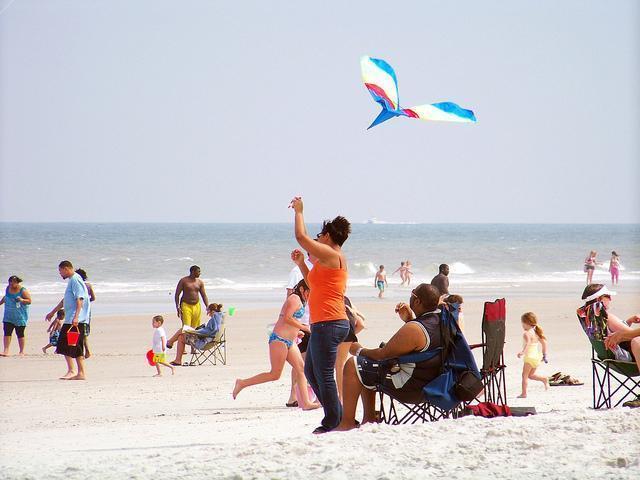How many chairs are there?
Give a very brief answer. 3. How many people can be seen?
Give a very brief answer. 4. 